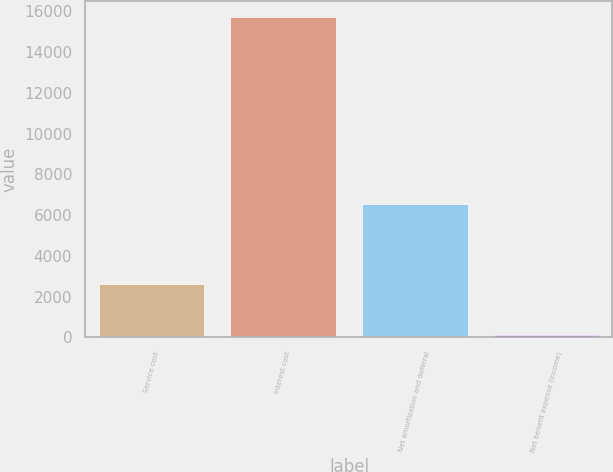Convert chart. <chart><loc_0><loc_0><loc_500><loc_500><bar_chart><fcel>Service cost<fcel>Interest cost<fcel>Net amortization and deferral<fcel>Net benefit expense (income)<nl><fcel>2615<fcel>15711<fcel>6567<fcel>107<nl></chart> 